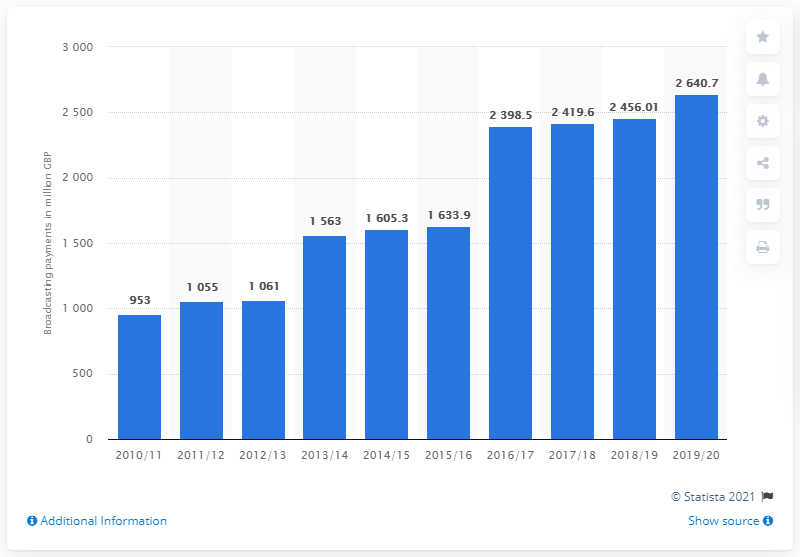Mention a couple of crucial points in this snapshot. In the 2019/2020 Premier League season, clubs received a total of 2640.7 British pounds in broadcasting payments. 